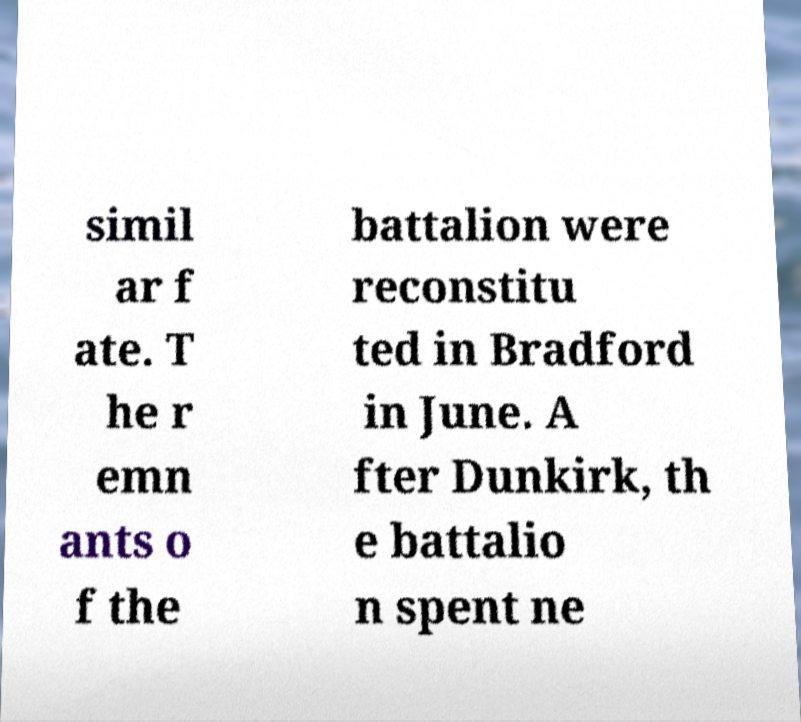Can you accurately transcribe the text from the provided image for me? simil ar f ate. T he r emn ants o f the battalion were reconstitu ted in Bradford in June. A fter Dunkirk, th e battalio n spent ne 